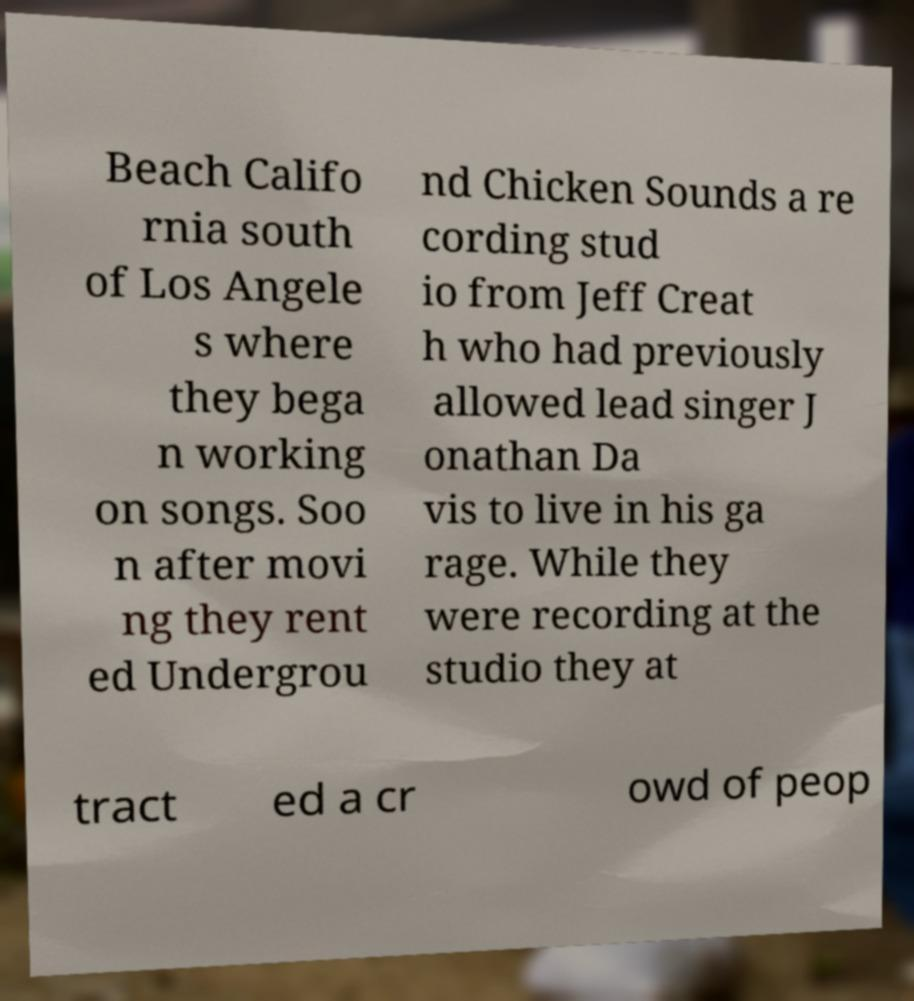Can you read and provide the text displayed in the image?This photo seems to have some interesting text. Can you extract and type it out for me? Beach Califo rnia south of Los Angele s where they bega n working on songs. Soo n after movi ng they rent ed Undergrou nd Chicken Sounds a re cording stud io from Jeff Creat h who had previously allowed lead singer J onathan Da vis to live in his ga rage. While they were recording at the studio they at tract ed a cr owd of peop 